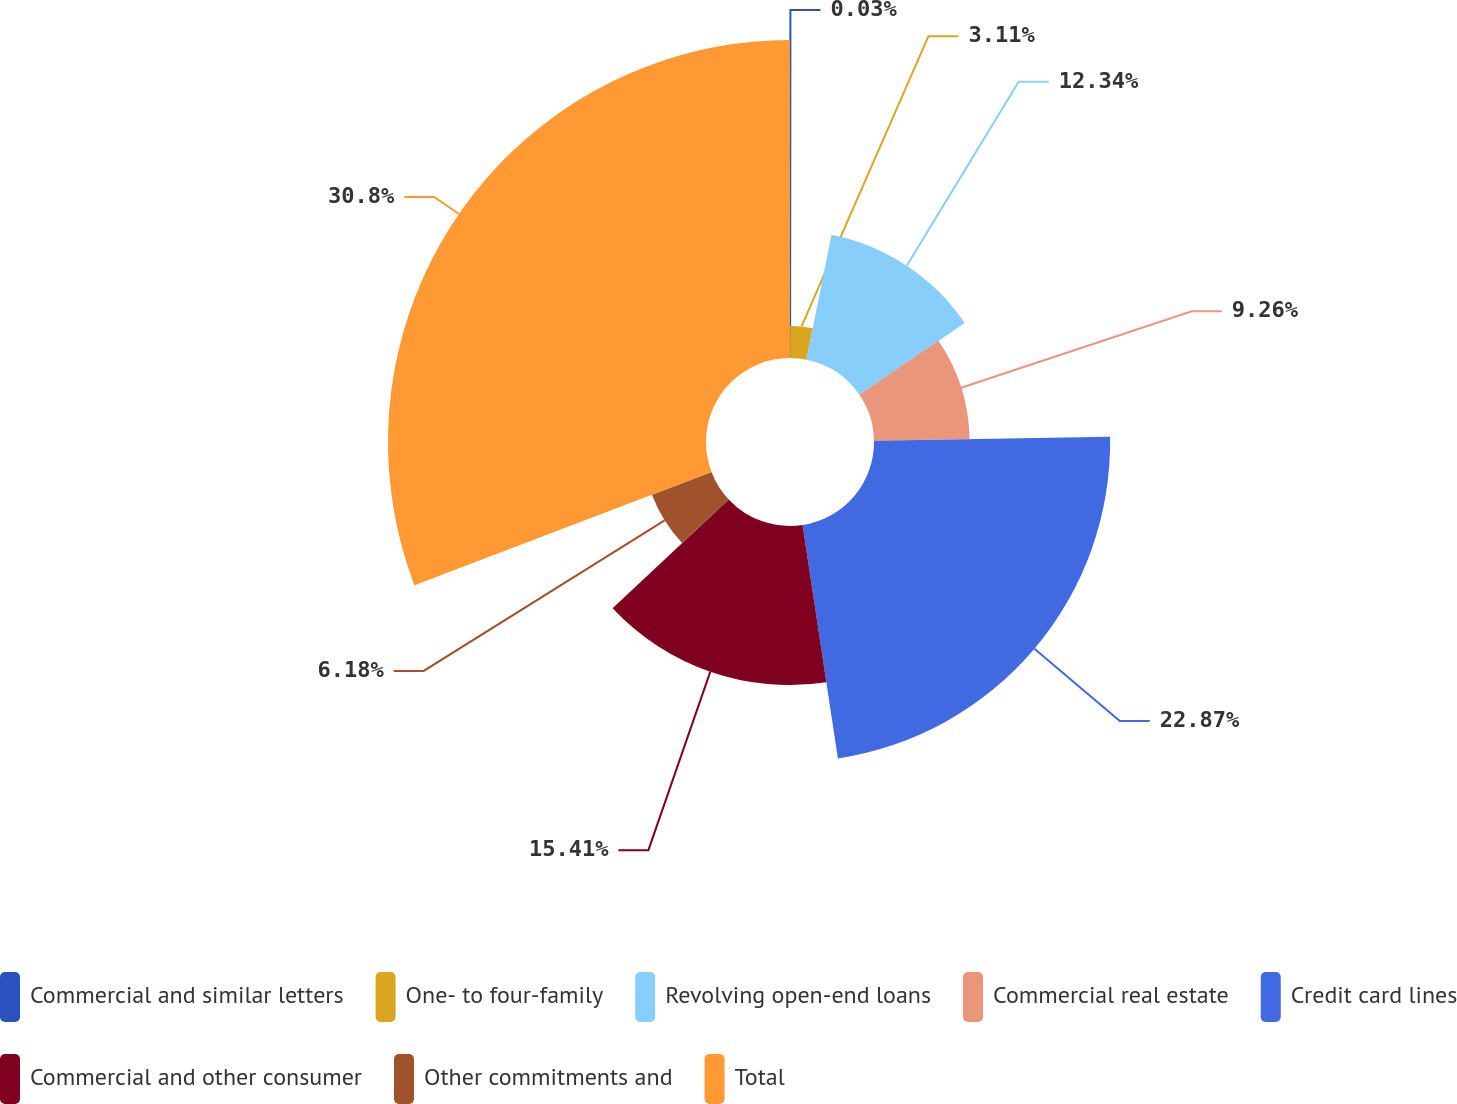Convert chart to OTSL. <chart><loc_0><loc_0><loc_500><loc_500><pie_chart><fcel>Commercial and similar letters<fcel>One- to four-family<fcel>Revolving open-end loans<fcel>Commercial real estate<fcel>Credit card lines<fcel>Commercial and other consumer<fcel>Other commitments and<fcel>Total<nl><fcel>0.03%<fcel>3.11%<fcel>12.34%<fcel>9.26%<fcel>22.87%<fcel>15.41%<fcel>6.18%<fcel>30.8%<nl></chart> 